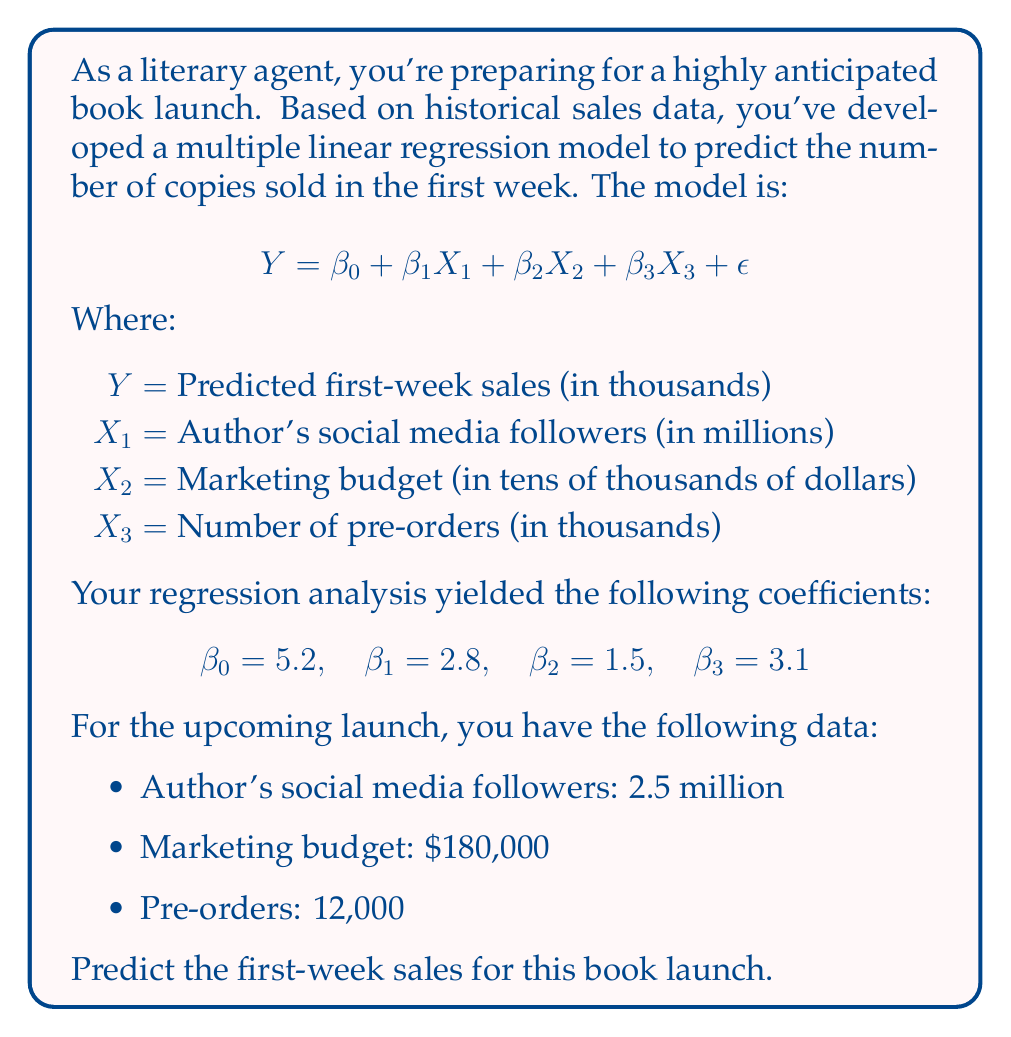Can you solve this math problem? To solve this problem, we need to substitute the given values into our regression equation:

1. First, let's identify our $X$ values:
   $X_1 = 2.5$ (2.5 million followers)
   $X_2 = 18$ ($180,000 / $10,000)
   $X_3 = 12$ (12,000 pre-orders)

2. Now, let's substitute these values and our coefficients into the equation:

   $$ Y = 5.2 + 2.8X_1 + 1.5X_2 + 3.1X_3 $$

3. Plugging in the values:

   $$ Y = 5.2 + 2.8(2.5) + 1.5(18) + 3.1(12) $$

4. Let's calculate each term:
   - $5.2$ (constant term)
   - $2.8 * 2.5 = 7$
   - $1.5 * 18 = 27$
   - $3.1 * 12 = 37.2$

5. Sum up all terms:

   $$ Y = 5.2 + 7 + 27 + 37.2 = 76.4 $$

6. Remember that $Y$ is in thousands of copies, so our prediction is 76,400 copies sold in the first week.
Answer: 76,400 copies 